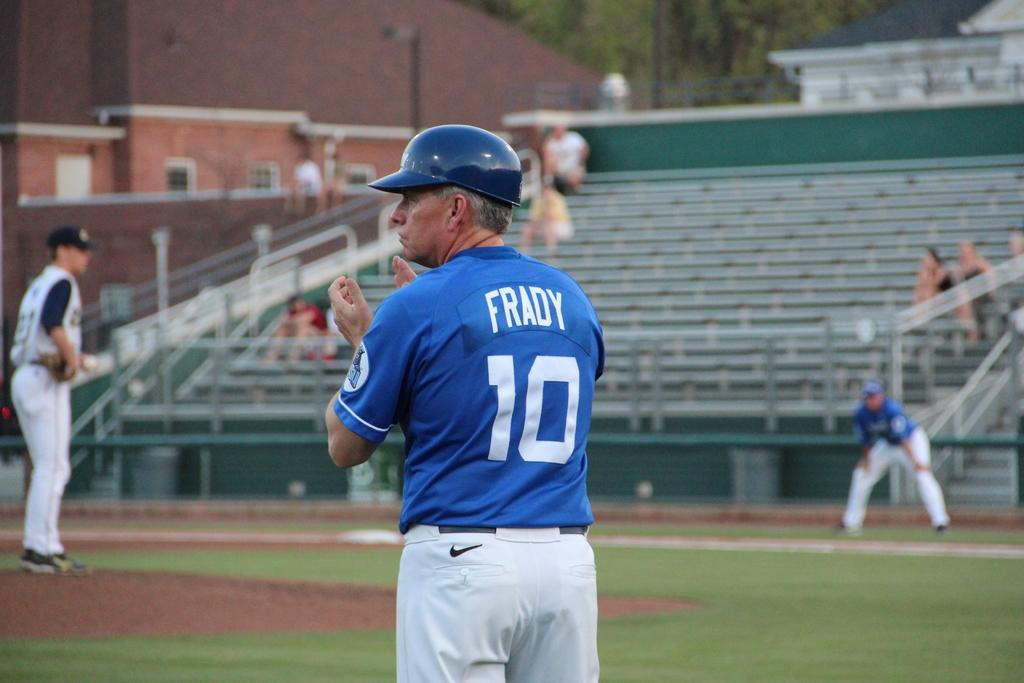How many men are standing on the ground in the image? There are three men standing on the ground in the image. What can be seen in the background of the image? In the background, there are people sitting on steps and buildings visible. Trees are also present in the background. Reasoning: Let's think step by step by step in order to produce the conversation. We start by identifying the main subjects in the image, which are the three men standing on the ground. Then, we expand the conversation to include other elements visible in the background, such as people sitting on steps, buildings, and trees. Each question is designed to elicit a specific detail about the image that is known from the provided facts. Absurd Question/Answer: What language are the people on the island speaking in the image? There is no island present in the image, and therefore no people to speak a language. 